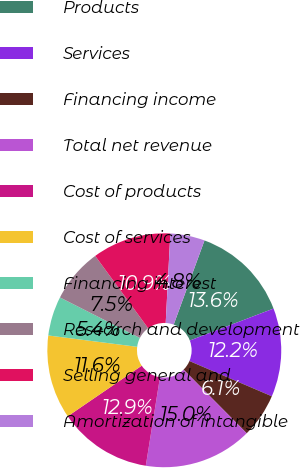<chart> <loc_0><loc_0><loc_500><loc_500><pie_chart><fcel>Products<fcel>Services<fcel>Financing income<fcel>Total net revenue<fcel>Cost of products<fcel>Cost of services<fcel>Financing interest<fcel>Research and development<fcel>Selling general and<fcel>Amortization of intangible<nl><fcel>13.61%<fcel>12.24%<fcel>6.12%<fcel>14.97%<fcel>12.93%<fcel>11.56%<fcel>5.44%<fcel>7.48%<fcel>10.88%<fcel>4.76%<nl></chart> 